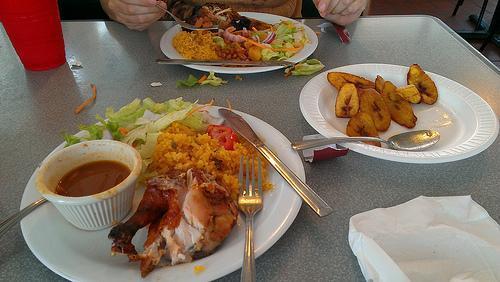How many plates are there?
Give a very brief answer. 3. 